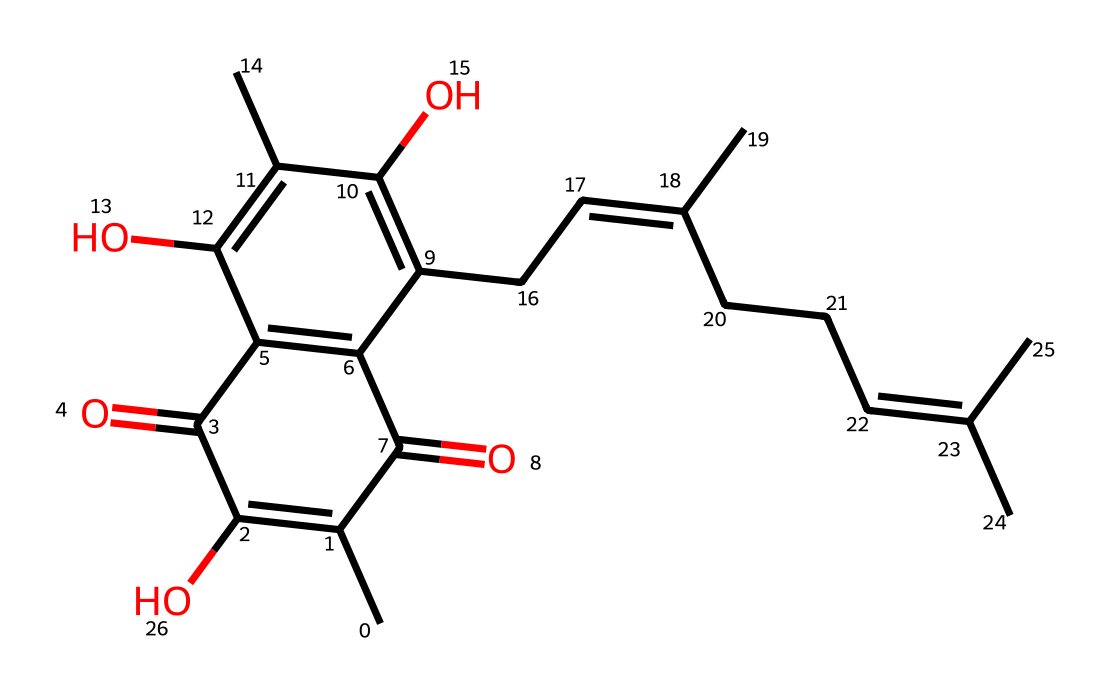How many carbon atoms are in this compound? Count the 'C' characters in the SMILES representation. Each 'C' corresponds to a carbon atom. There are a total of 28 'C' characters in the provided SMILES.
Answer: 28 What is the main functional group present in this structure? Identify the functional groups by looking for characteristic features in the SMILES. The structure contains multiple 'C(=O)' which indicate carbonyls and 'O' which indicates hydroxyls. The most prominent functional group is the ketone (since there are two carbonyl groups).
Answer: ketone Are there any double bonds in this compound? Scan the SMILES for '=' signs which indicate double bonds. The presence of 'C=C' shows the molecule contains multiple double bonds.
Answer: yes How many hydroxyl (–OH) groups are in this compound? Identify 'O' without carbonyl characters. The 'C(=C(O)' and similar structures indicate hydroxyl groups. By counting, we find four –OH groups.
Answer: 4 What type of organic compound does this structure belong to? Analyze the overall structure and functional groups. Given the complexity and the presence of multiple rings and functional groups, this compound is likely a flavonoid.
Answer: flavonoid Which part of this chemical contributes to its magnetic properties? Look for features likely influencing magnetic properties. The conjugated π-systems (due to double bonds and rings) potentially allow for resonance forms that can stabilize unpaired electrons, highlighting a possible connection to magnetic properties.
Answer: conjugated π-system 